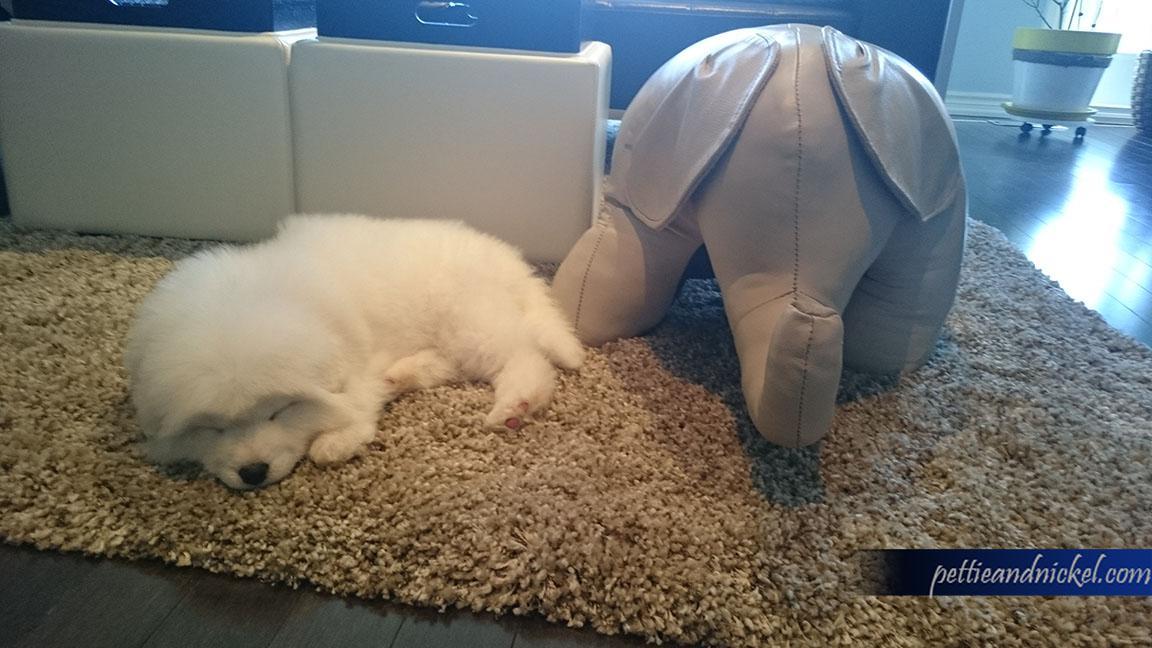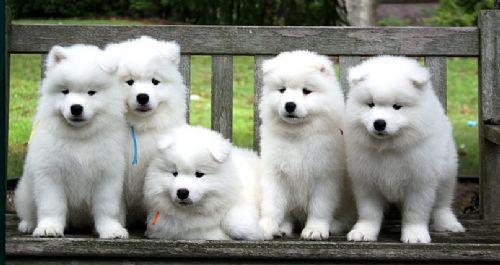The first image is the image on the left, the second image is the image on the right. Given the left and right images, does the statement "An image features one white dog sleeping near one stuffed animal toy." hold true? Answer yes or no. Yes. The first image is the image on the left, the second image is the image on the right. Examine the images to the left and right. Is the description "The right image contains at least three white dogs." accurate? Answer yes or no. Yes. 